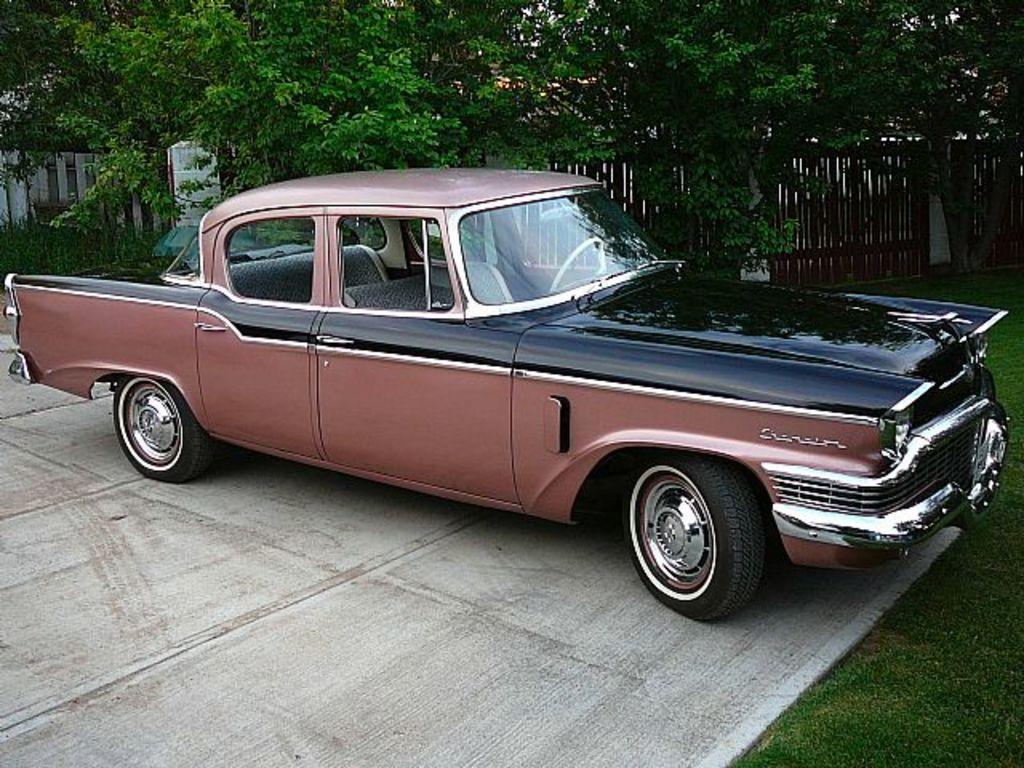Could you give a brief overview of what you see in this image? In the picture we can see a vintage car which is parked on the path the car is brown in color and some part black in color and besides the path we can see grass surface and far away from it we can see railing and trees. 